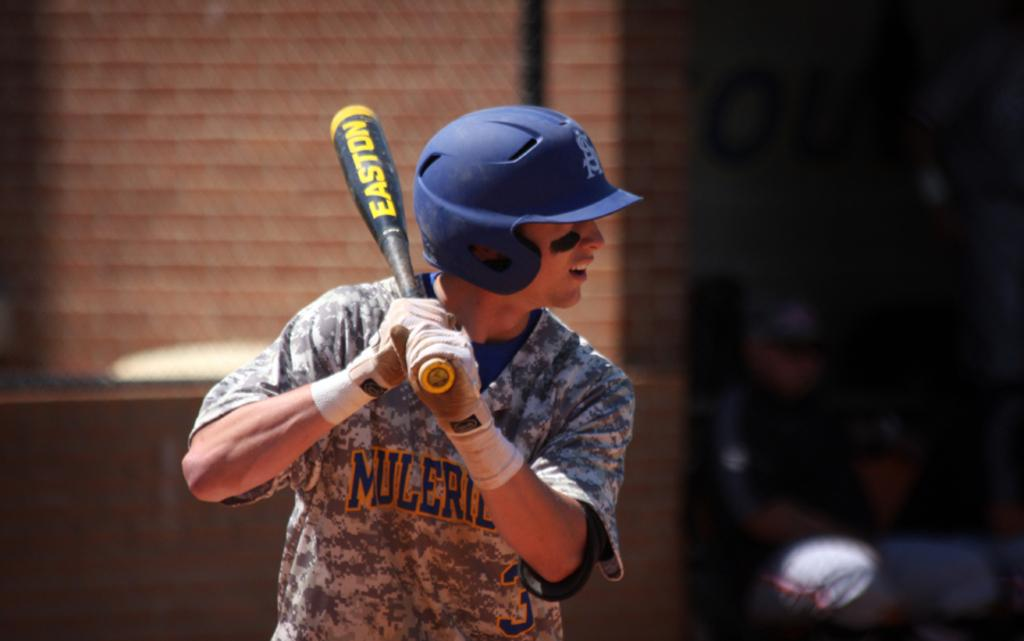What is the main subject of the image? There is a person in the image. What is the person doing in the image? The person is standing and holding a baseball bat. What protective gear is the person wearing? The person is wearing a blue helmet. Can you describe the background of the image? The background of the image is blurred. What type of company is advertised on the sign in the image? There is no sign present in the image, so it is not possible to determine what type of company might be advertised. 